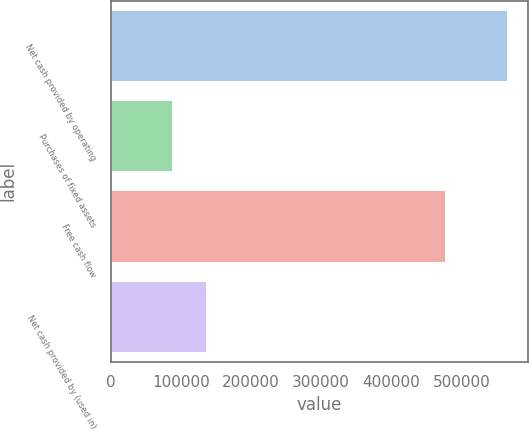Convert chart to OTSL. <chart><loc_0><loc_0><loc_500><loc_500><bar_chart><fcel>Net cash provided by operating<fcel>Purchases of fixed assets<fcel>Free cash flow<fcel>Net cash provided by (used in)<nl><fcel>566560<fcel>89133<fcel>477427<fcel>136876<nl></chart> 